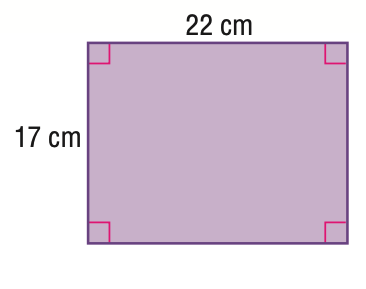Answer the mathemtical geometry problem and directly provide the correct option letter.
Question: Find the area of the figure. Round to the nearest tenth.
Choices: A: 78 B: 364 C: 374 D: 484 C 